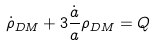Convert formula to latex. <formula><loc_0><loc_0><loc_500><loc_500>\dot { \rho } _ { D M } + 3 \frac { \dot { a } } { a } \rho _ { D M } = Q</formula> 